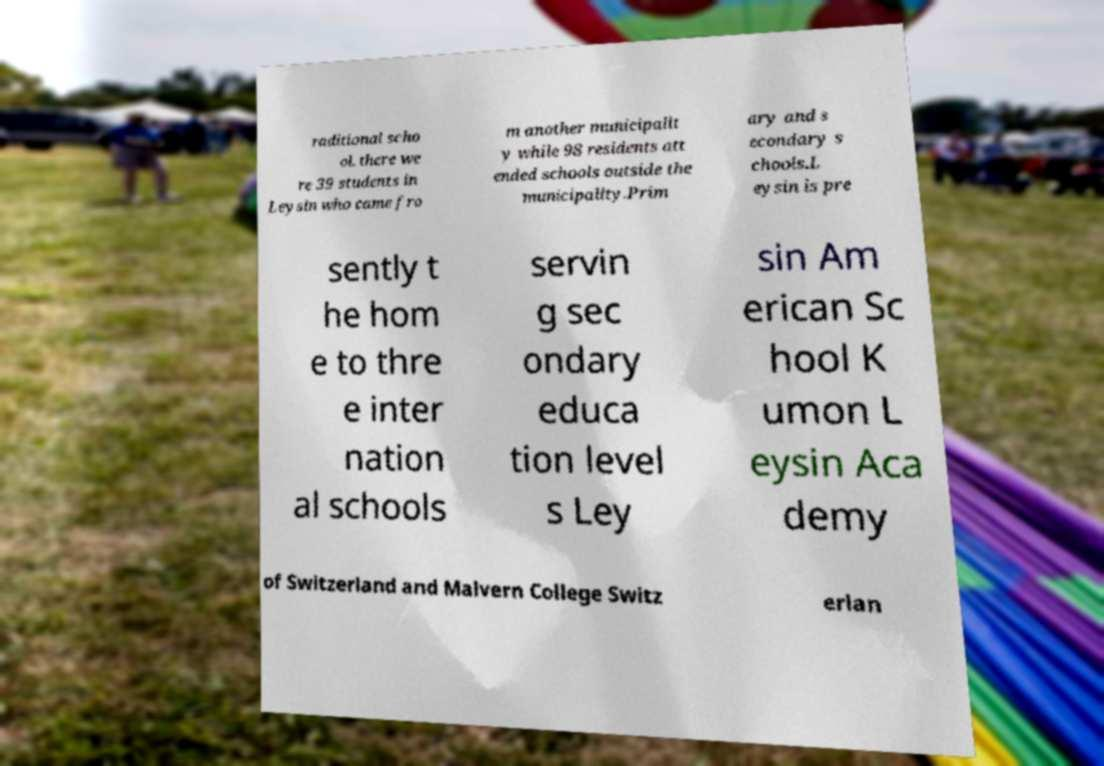Please read and relay the text visible in this image. What does it say? raditional scho ol. there we re 39 students in Leysin who came fro m another municipalit y while 98 residents att ended schools outside the municipality.Prim ary and s econdary s chools.L eysin is pre sently t he hom e to thre e inter nation al schools servin g sec ondary educa tion level s Ley sin Am erican Sc hool K umon L eysin Aca demy of Switzerland and Malvern College Switz erlan 